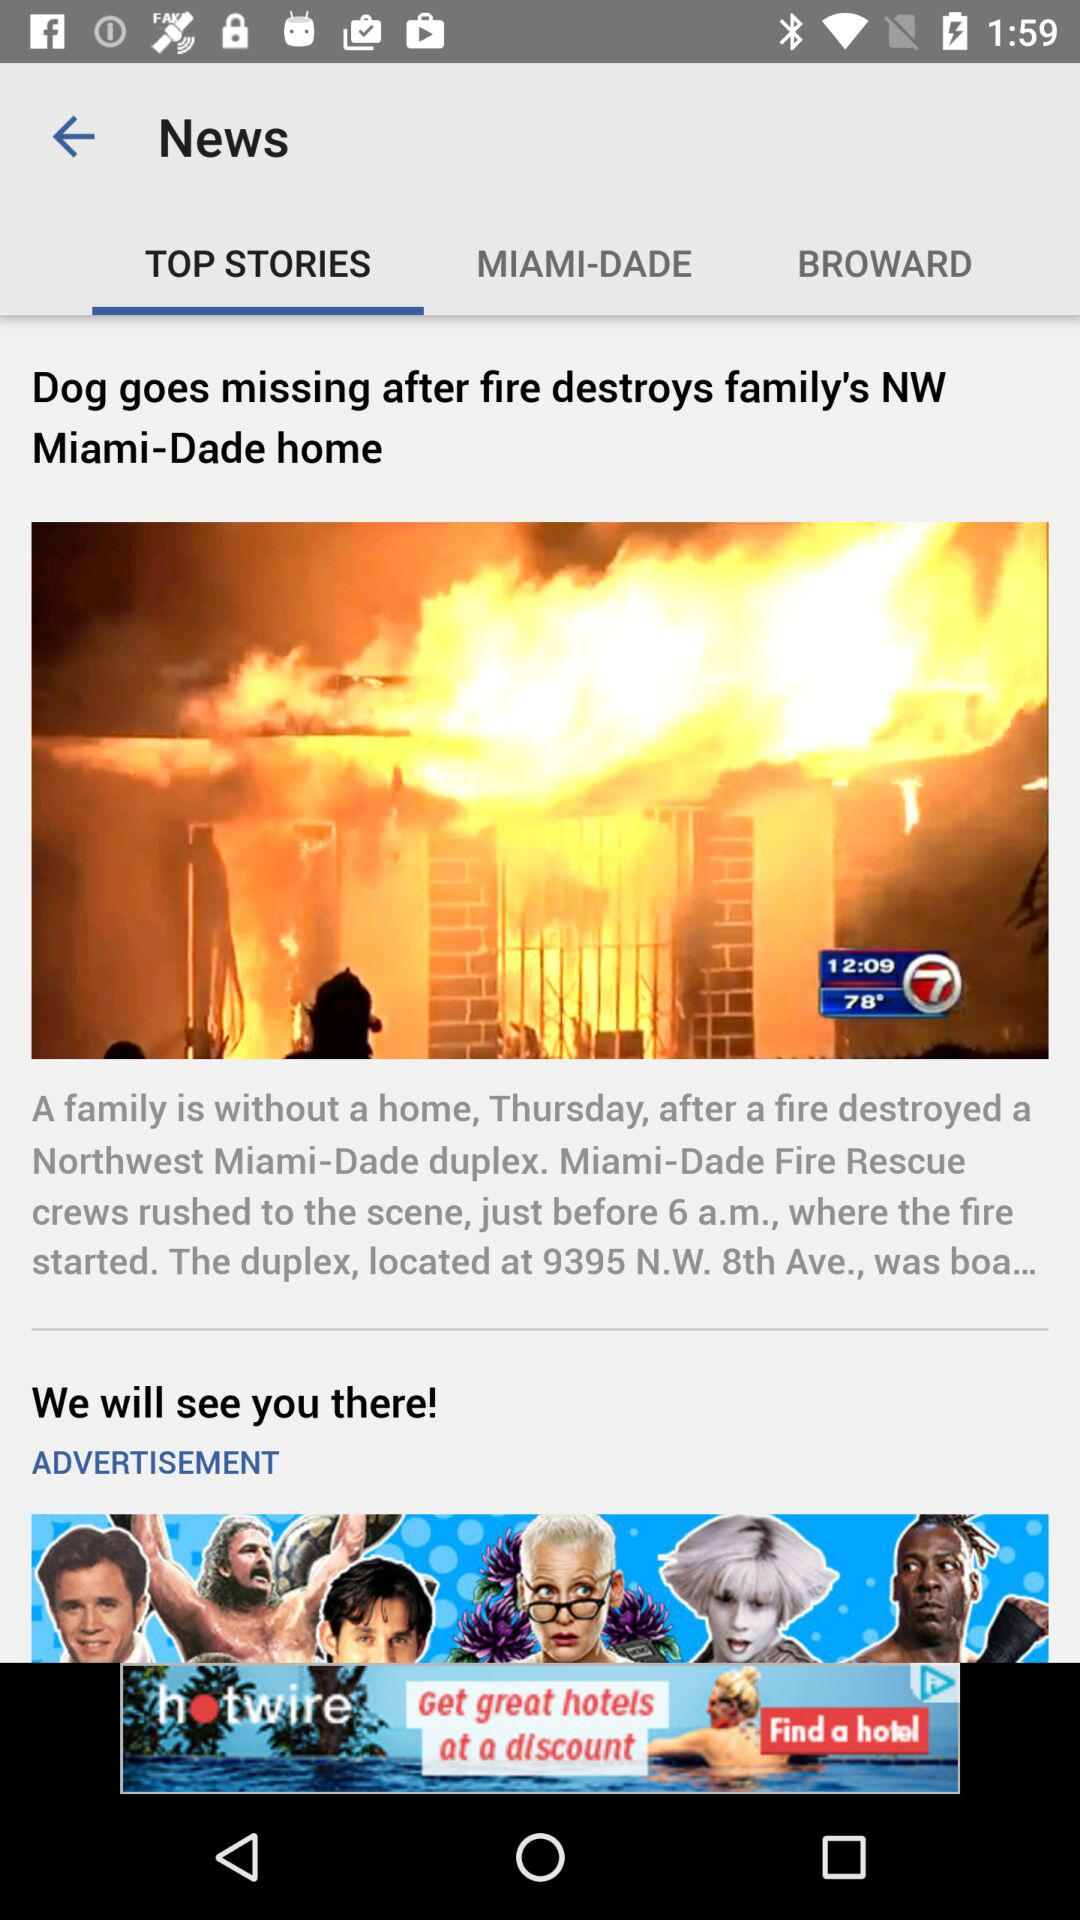Which tab is currently selected? The selected tab is "TOP STORIES". 